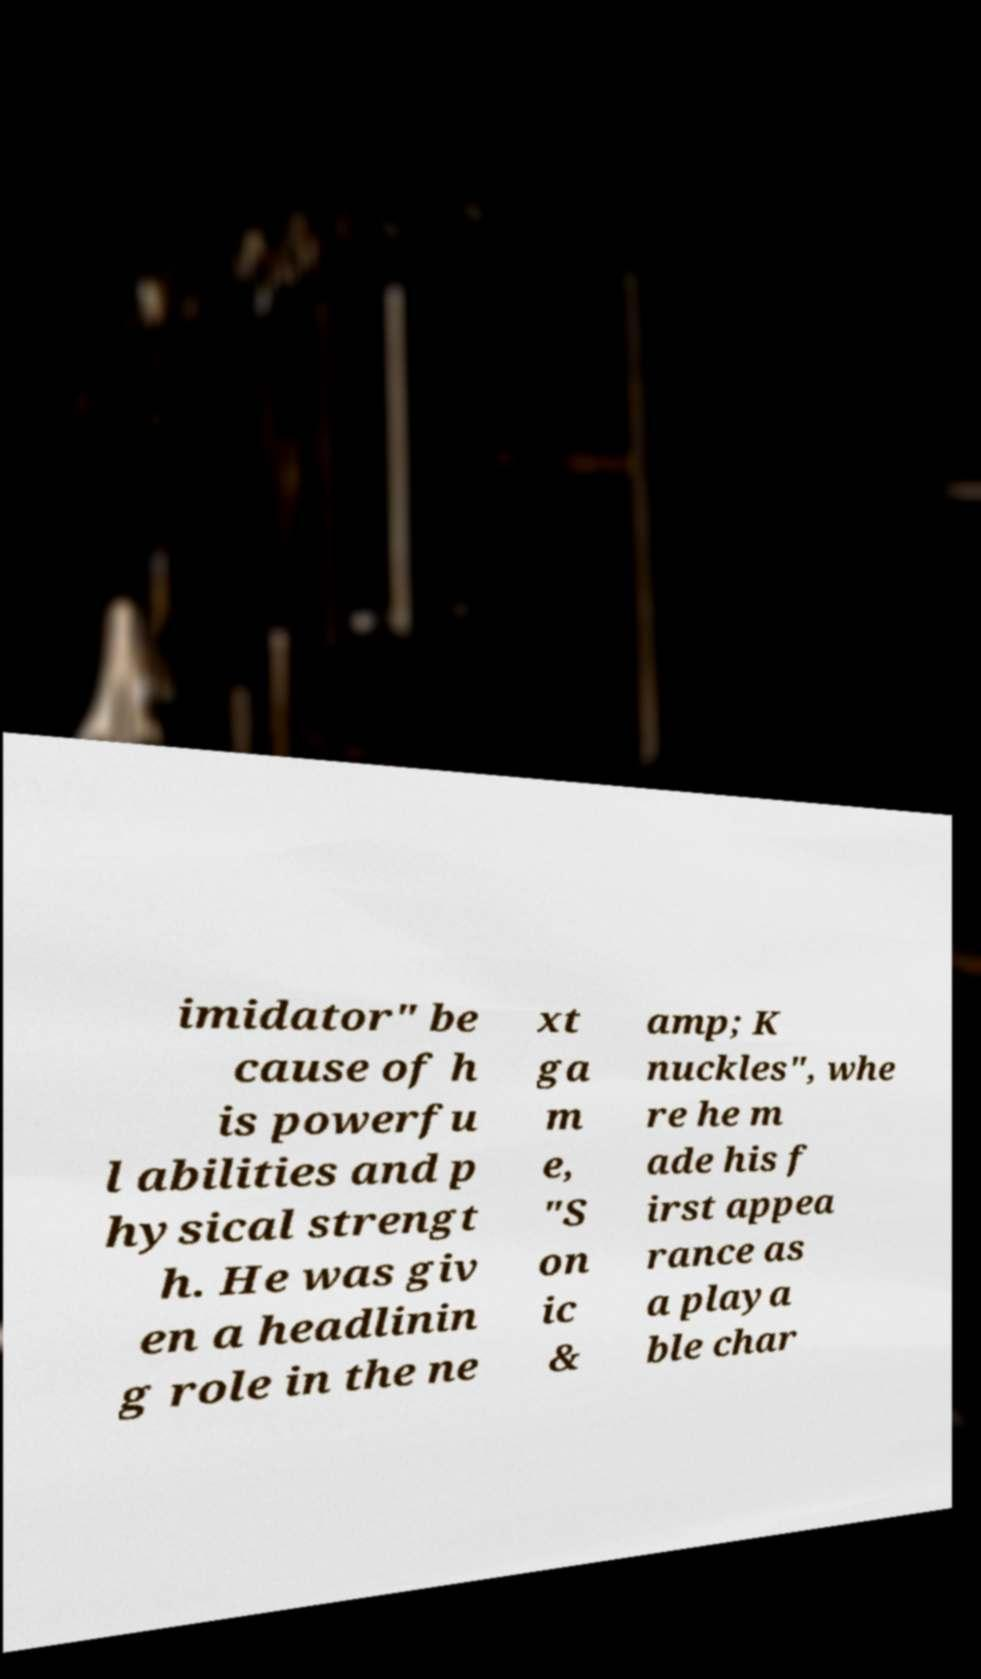There's text embedded in this image that I need extracted. Can you transcribe it verbatim? imidator" be cause of h is powerfu l abilities and p hysical strengt h. He was giv en a headlinin g role in the ne xt ga m e, "S on ic & amp; K nuckles", whe re he m ade his f irst appea rance as a playa ble char 